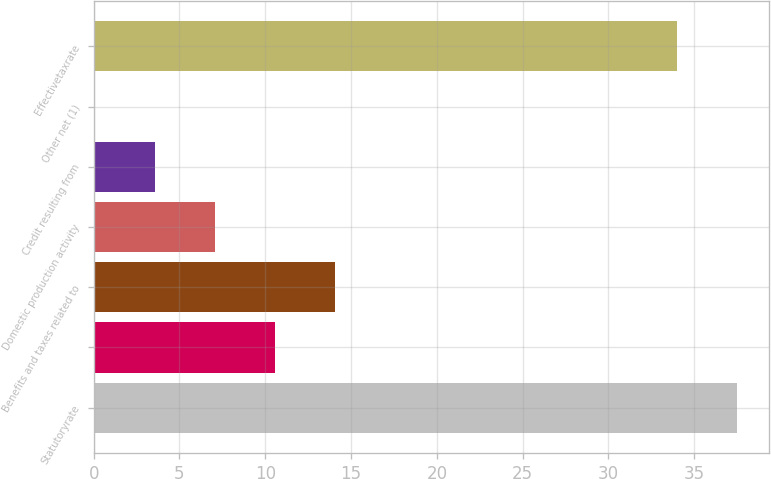<chart> <loc_0><loc_0><loc_500><loc_500><bar_chart><fcel>Statutoryrate<fcel>Unnamed: 1<fcel>Benefits and taxes related to<fcel>Domestic production activity<fcel>Credit resulting from<fcel>Other net (1)<fcel>Effectivetaxrate<nl><fcel>37.49<fcel>10.57<fcel>14.06<fcel>7.08<fcel>3.59<fcel>0.1<fcel>34<nl></chart> 